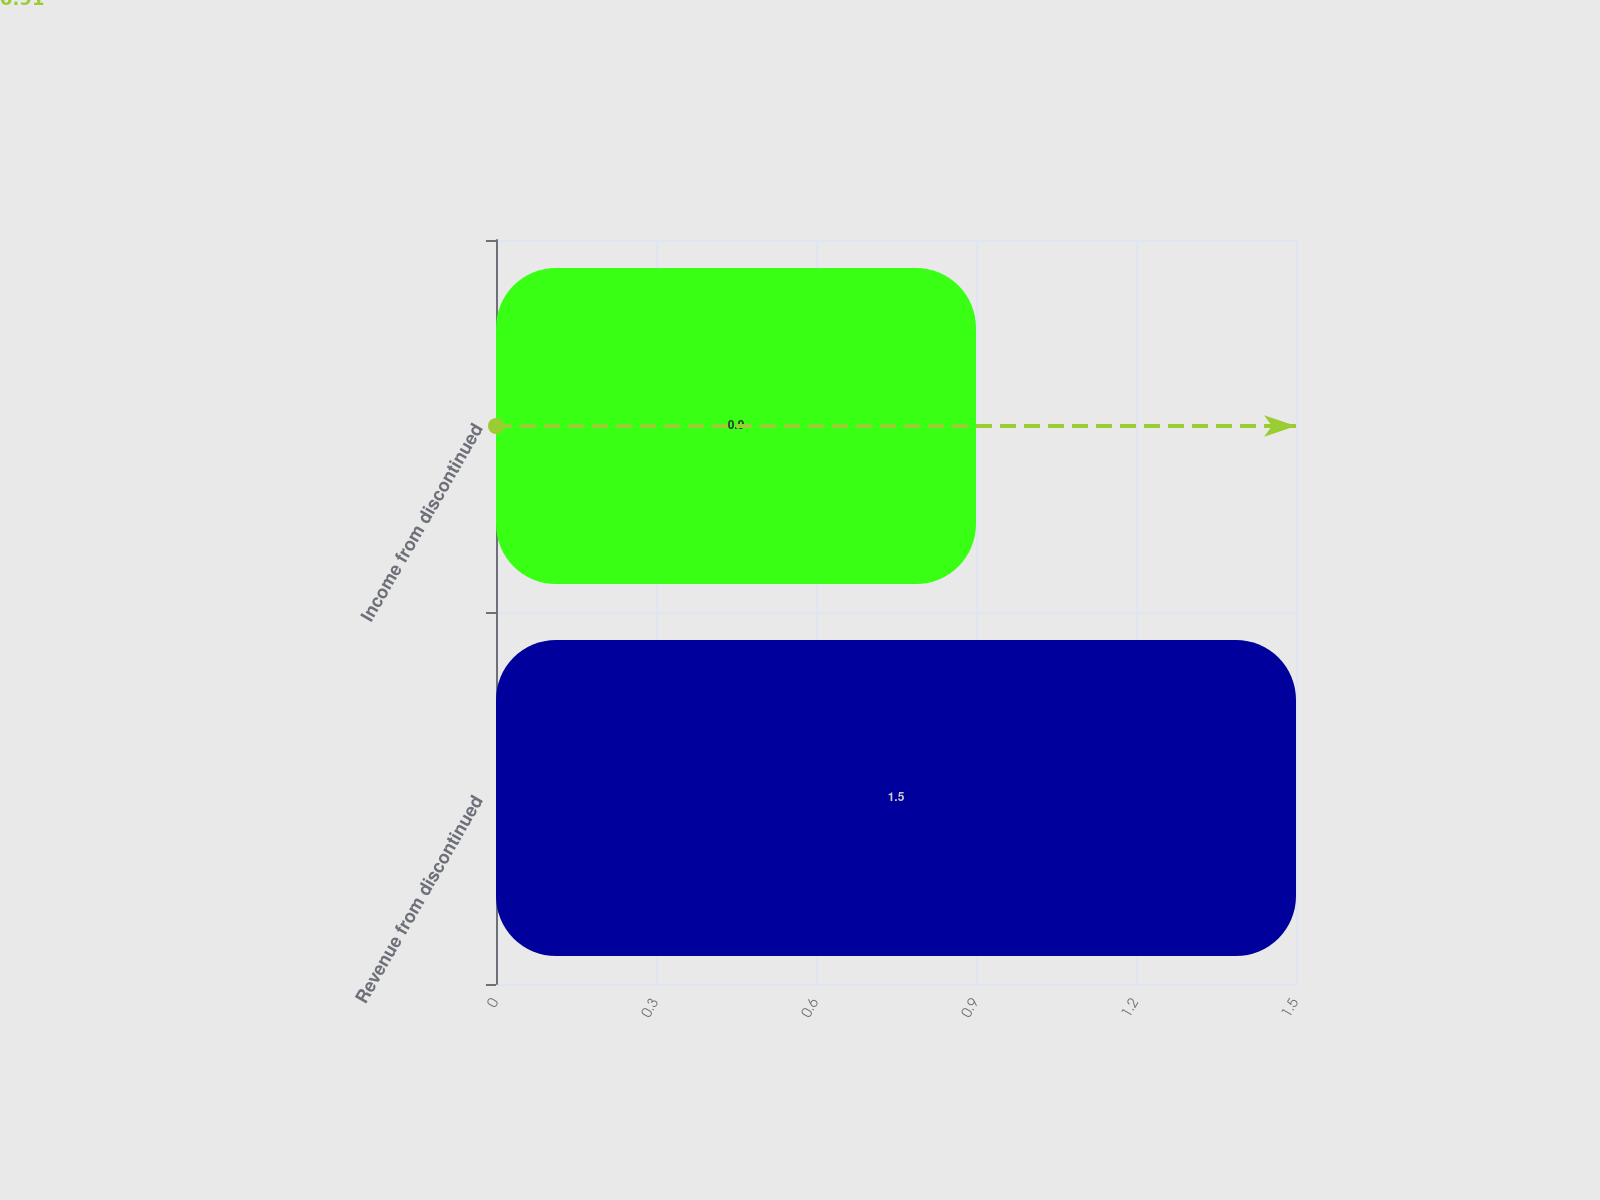Convert chart to OTSL. <chart><loc_0><loc_0><loc_500><loc_500><bar_chart><fcel>Revenue from discontinued<fcel>Income from discontinued<nl><fcel>1.5<fcel>0.9<nl></chart> 